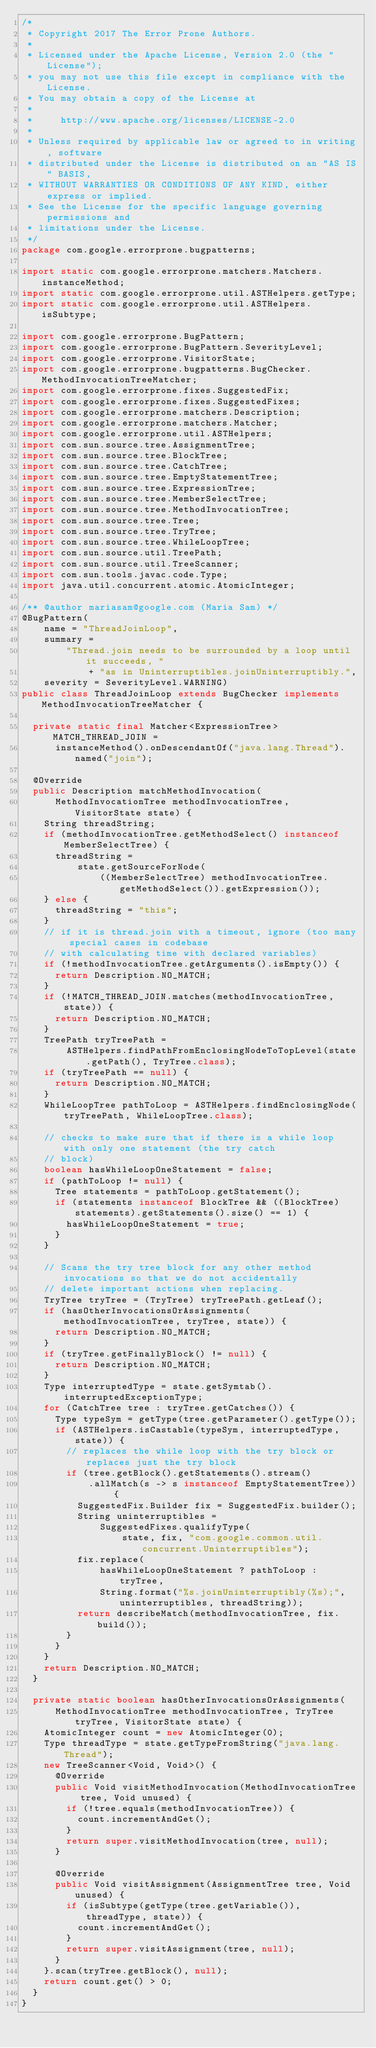Convert code to text. <code><loc_0><loc_0><loc_500><loc_500><_Java_>/*
 * Copyright 2017 The Error Prone Authors.
 *
 * Licensed under the Apache License, Version 2.0 (the "License");
 * you may not use this file except in compliance with the License.
 * You may obtain a copy of the License at
 *
 *     http://www.apache.org/licenses/LICENSE-2.0
 *
 * Unless required by applicable law or agreed to in writing, software
 * distributed under the License is distributed on an "AS IS" BASIS,
 * WITHOUT WARRANTIES OR CONDITIONS OF ANY KIND, either express or implied.
 * See the License for the specific language governing permissions and
 * limitations under the License.
 */
package com.google.errorprone.bugpatterns;

import static com.google.errorprone.matchers.Matchers.instanceMethod;
import static com.google.errorprone.util.ASTHelpers.getType;
import static com.google.errorprone.util.ASTHelpers.isSubtype;

import com.google.errorprone.BugPattern;
import com.google.errorprone.BugPattern.SeverityLevel;
import com.google.errorprone.VisitorState;
import com.google.errorprone.bugpatterns.BugChecker.MethodInvocationTreeMatcher;
import com.google.errorprone.fixes.SuggestedFix;
import com.google.errorprone.fixes.SuggestedFixes;
import com.google.errorprone.matchers.Description;
import com.google.errorprone.matchers.Matcher;
import com.google.errorprone.util.ASTHelpers;
import com.sun.source.tree.AssignmentTree;
import com.sun.source.tree.BlockTree;
import com.sun.source.tree.CatchTree;
import com.sun.source.tree.EmptyStatementTree;
import com.sun.source.tree.ExpressionTree;
import com.sun.source.tree.MemberSelectTree;
import com.sun.source.tree.MethodInvocationTree;
import com.sun.source.tree.Tree;
import com.sun.source.tree.TryTree;
import com.sun.source.tree.WhileLoopTree;
import com.sun.source.util.TreePath;
import com.sun.source.util.TreeScanner;
import com.sun.tools.javac.code.Type;
import java.util.concurrent.atomic.AtomicInteger;

/** @author mariasam@google.com (Maria Sam) */
@BugPattern(
    name = "ThreadJoinLoop",
    summary =
        "Thread.join needs to be surrounded by a loop until it succeeds, "
            + "as in Uninterruptibles.joinUninterruptibly.",
    severity = SeverityLevel.WARNING)
public class ThreadJoinLoop extends BugChecker implements MethodInvocationTreeMatcher {

  private static final Matcher<ExpressionTree> MATCH_THREAD_JOIN =
      instanceMethod().onDescendantOf("java.lang.Thread").named("join");

  @Override
  public Description matchMethodInvocation(
      MethodInvocationTree methodInvocationTree, VisitorState state) {
    String threadString;
    if (methodInvocationTree.getMethodSelect() instanceof MemberSelectTree) {
      threadString =
          state.getSourceForNode(
              ((MemberSelectTree) methodInvocationTree.getMethodSelect()).getExpression());
    } else {
      threadString = "this";
    }
    // if it is thread.join with a timeout, ignore (too many special cases in codebase
    // with calculating time with declared variables)
    if (!methodInvocationTree.getArguments().isEmpty()) {
      return Description.NO_MATCH;
    }
    if (!MATCH_THREAD_JOIN.matches(methodInvocationTree, state)) {
      return Description.NO_MATCH;
    }
    TreePath tryTreePath =
        ASTHelpers.findPathFromEnclosingNodeToTopLevel(state.getPath(), TryTree.class);
    if (tryTreePath == null) {
      return Description.NO_MATCH;
    }
    WhileLoopTree pathToLoop = ASTHelpers.findEnclosingNode(tryTreePath, WhileLoopTree.class);

    // checks to make sure that if there is a while loop with only one statement (the try catch
    // block)
    boolean hasWhileLoopOneStatement = false;
    if (pathToLoop != null) {
      Tree statements = pathToLoop.getStatement();
      if (statements instanceof BlockTree && ((BlockTree) statements).getStatements().size() == 1) {
        hasWhileLoopOneStatement = true;
      }
    }

    // Scans the try tree block for any other method invocations so that we do not accidentally
    // delete important actions when replacing.
    TryTree tryTree = (TryTree) tryTreePath.getLeaf();
    if (hasOtherInvocationsOrAssignments(methodInvocationTree, tryTree, state)) {
      return Description.NO_MATCH;
    }
    if (tryTree.getFinallyBlock() != null) {
      return Description.NO_MATCH;
    }
    Type interruptedType = state.getSymtab().interruptedExceptionType;
    for (CatchTree tree : tryTree.getCatches()) {
      Type typeSym = getType(tree.getParameter().getType());
      if (ASTHelpers.isCastable(typeSym, interruptedType, state)) {
        // replaces the while loop with the try block or replaces just the try block
        if (tree.getBlock().getStatements().stream()
            .allMatch(s -> s instanceof EmptyStatementTree)) {
          SuggestedFix.Builder fix = SuggestedFix.builder();
          String uninterruptibles =
              SuggestedFixes.qualifyType(
                  state, fix, "com.google.common.util.concurrent.Uninterruptibles");
          fix.replace(
              hasWhileLoopOneStatement ? pathToLoop : tryTree,
              String.format("%s.joinUninterruptibly(%s);", uninterruptibles, threadString));
          return describeMatch(methodInvocationTree, fix.build());
        }
      }
    }
    return Description.NO_MATCH;
  }

  private static boolean hasOtherInvocationsOrAssignments(
      MethodInvocationTree methodInvocationTree, TryTree tryTree, VisitorState state) {
    AtomicInteger count = new AtomicInteger(0);
    Type threadType = state.getTypeFromString("java.lang.Thread");
    new TreeScanner<Void, Void>() {
      @Override
      public Void visitMethodInvocation(MethodInvocationTree tree, Void unused) {
        if (!tree.equals(methodInvocationTree)) {
          count.incrementAndGet();
        }
        return super.visitMethodInvocation(tree, null);
      }

      @Override
      public Void visitAssignment(AssignmentTree tree, Void unused) {
        if (isSubtype(getType(tree.getVariable()), threadType, state)) {
          count.incrementAndGet();
        }
        return super.visitAssignment(tree, null);
      }
    }.scan(tryTree.getBlock(), null);
    return count.get() > 0;
  }
}
</code> 